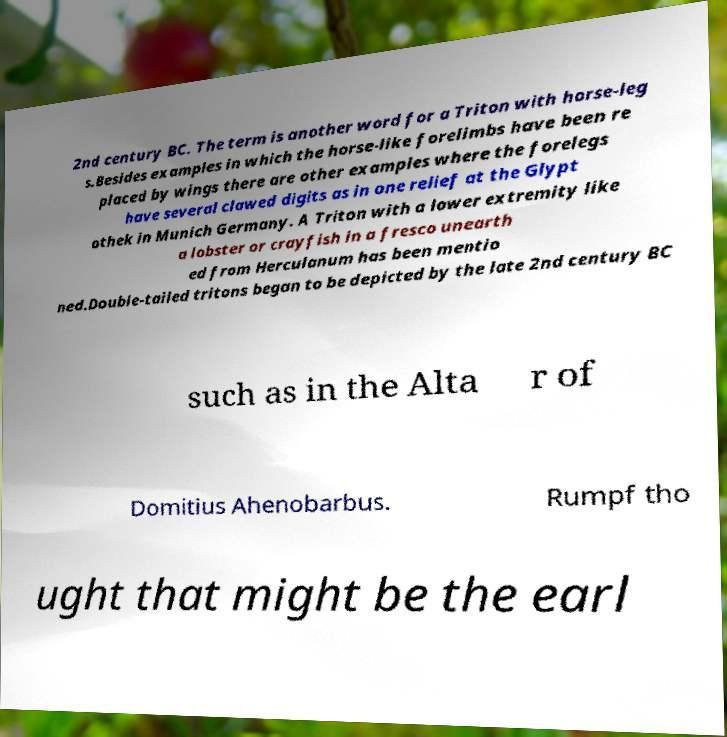Please read and relay the text visible in this image. What does it say? 2nd century BC. The term is another word for a Triton with horse-leg s.Besides examples in which the horse-like forelimbs have been re placed by wings there are other examples where the forelegs have several clawed digits as in one relief at the Glypt othek in Munich Germany. A Triton with a lower extremity like a lobster or crayfish in a fresco unearth ed from Herculanum has been mentio ned.Double-tailed tritons began to be depicted by the late 2nd century BC such as in the Alta r of Domitius Ahenobarbus. Rumpf tho ught that might be the earl 